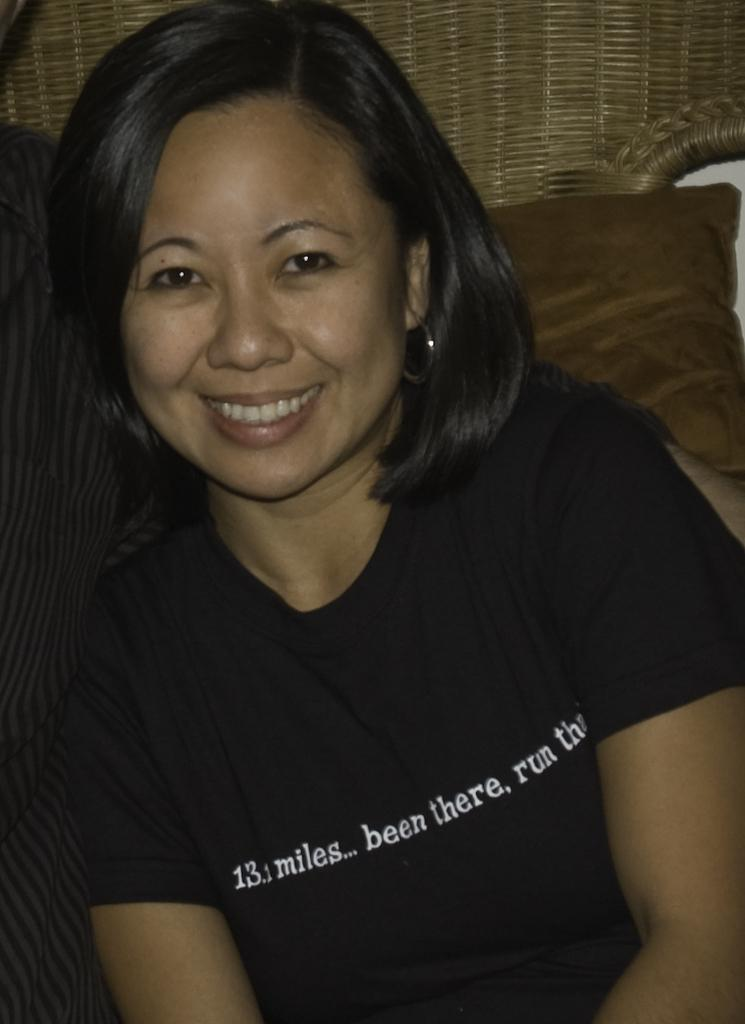Who is the main subject in the image? There is a woman in the image. What is the woman doing in the image? The woman is sitting in the image. What is the woman's facial expression in the image? The woman is smiling in the image. What is the woman wearing in the image? The woman is wearing a black t-shirt in the image. What type of hat is the woman wearing in the image? There is no hat present in the image; the woman is wearing a black t-shirt. 